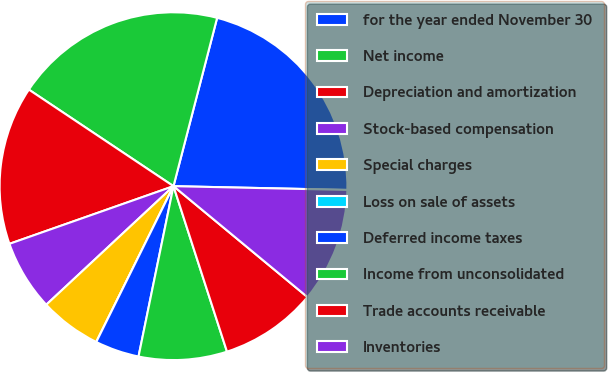Convert chart. <chart><loc_0><loc_0><loc_500><loc_500><pie_chart><fcel>for the year ended November 30<fcel>Net income<fcel>Depreciation and amortization<fcel>Stock-based compensation<fcel>Special charges<fcel>Loss on sale of assets<fcel>Deferred income taxes<fcel>Income from unconsolidated<fcel>Trade accounts receivable<fcel>Inventories<nl><fcel>21.31%<fcel>19.67%<fcel>14.75%<fcel>6.56%<fcel>5.74%<fcel>0.0%<fcel>4.1%<fcel>8.2%<fcel>9.02%<fcel>10.66%<nl></chart> 